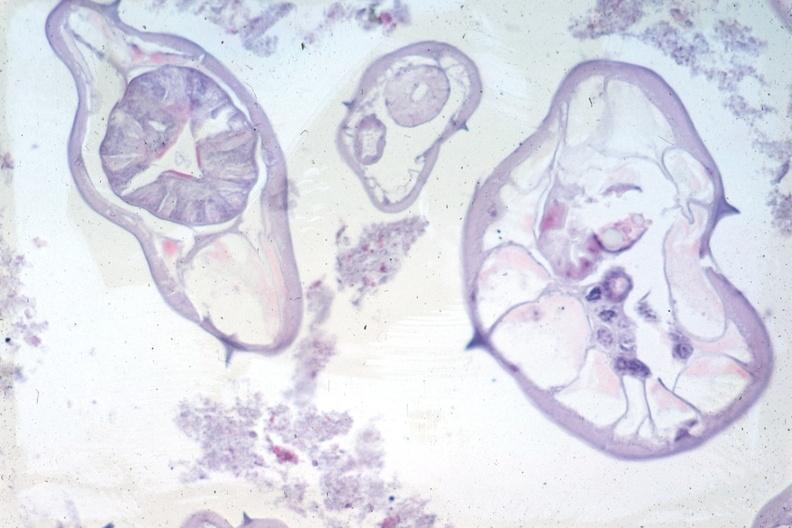what is present?
Answer the question using a single word or phrase. Gastrointestinal 